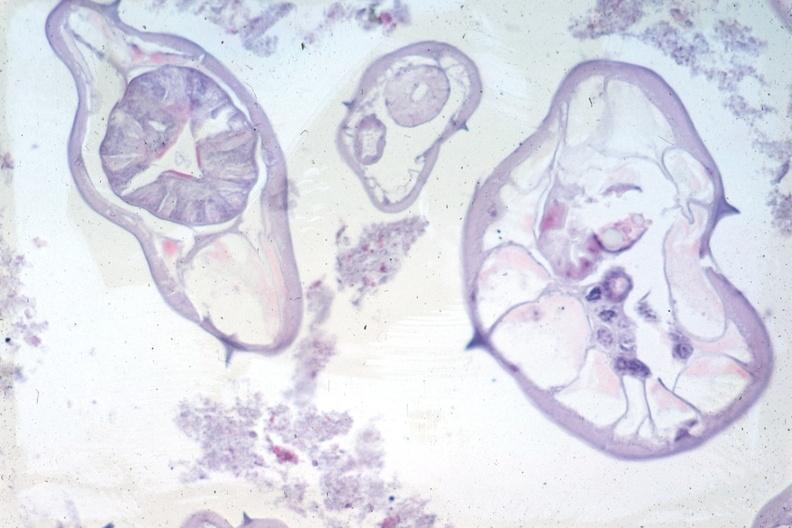what is present?
Answer the question using a single word or phrase. Gastrointestinal 